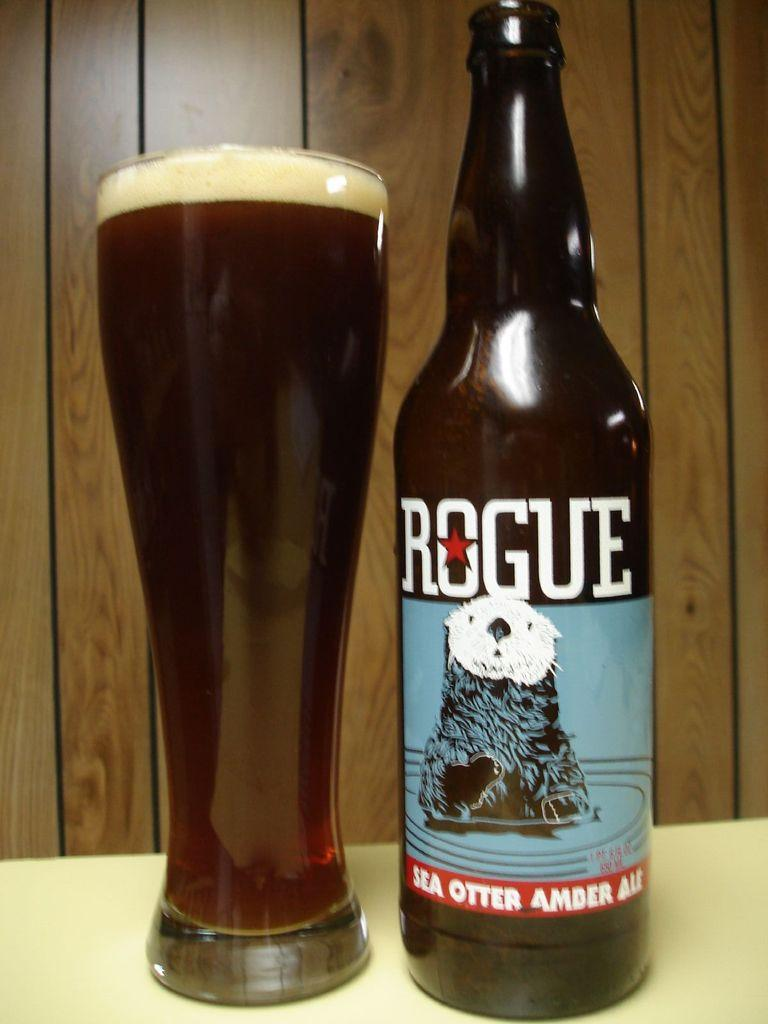<image>
Relay a brief, clear account of the picture shown. A tall glass of dark beer with a little froth at the top is next to an open bottle of Rogue Sea Otter Amber Ale. 